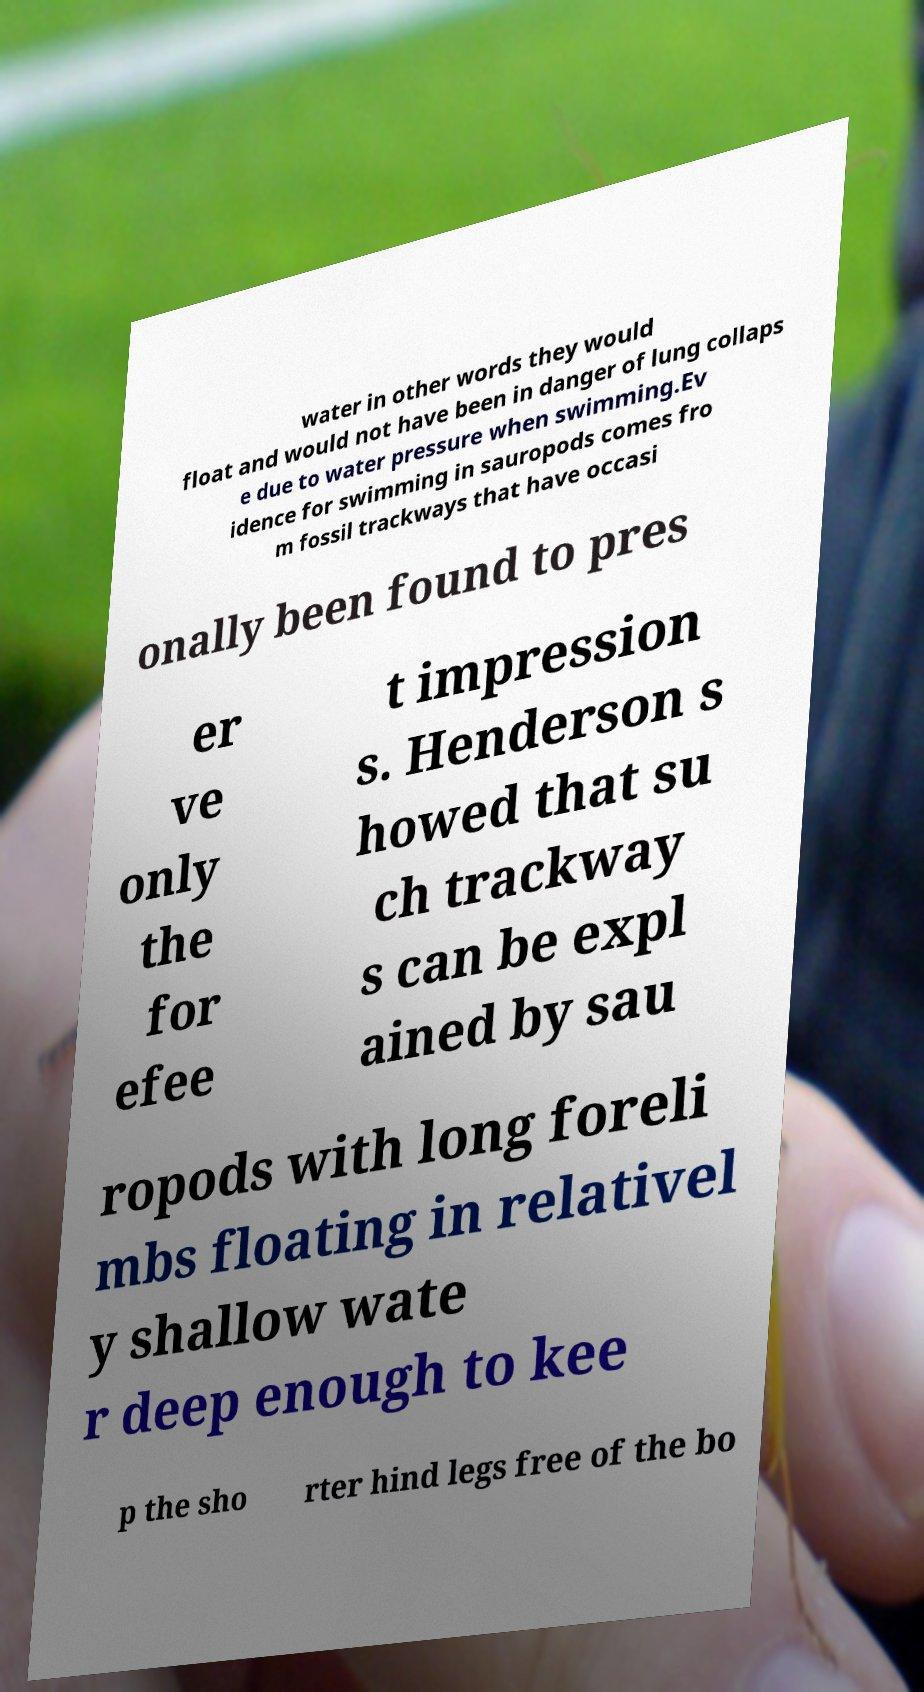There's text embedded in this image that I need extracted. Can you transcribe it verbatim? water in other words they would float and would not have been in danger of lung collaps e due to water pressure when swimming.Ev idence for swimming in sauropods comes fro m fossil trackways that have occasi onally been found to pres er ve only the for efee t impression s. Henderson s howed that su ch trackway s can be expl ained by sau ropods with long foreli mbs floating in relativel y shallow wate r deep enough to kee p the sho rter hind legs free of the bo 